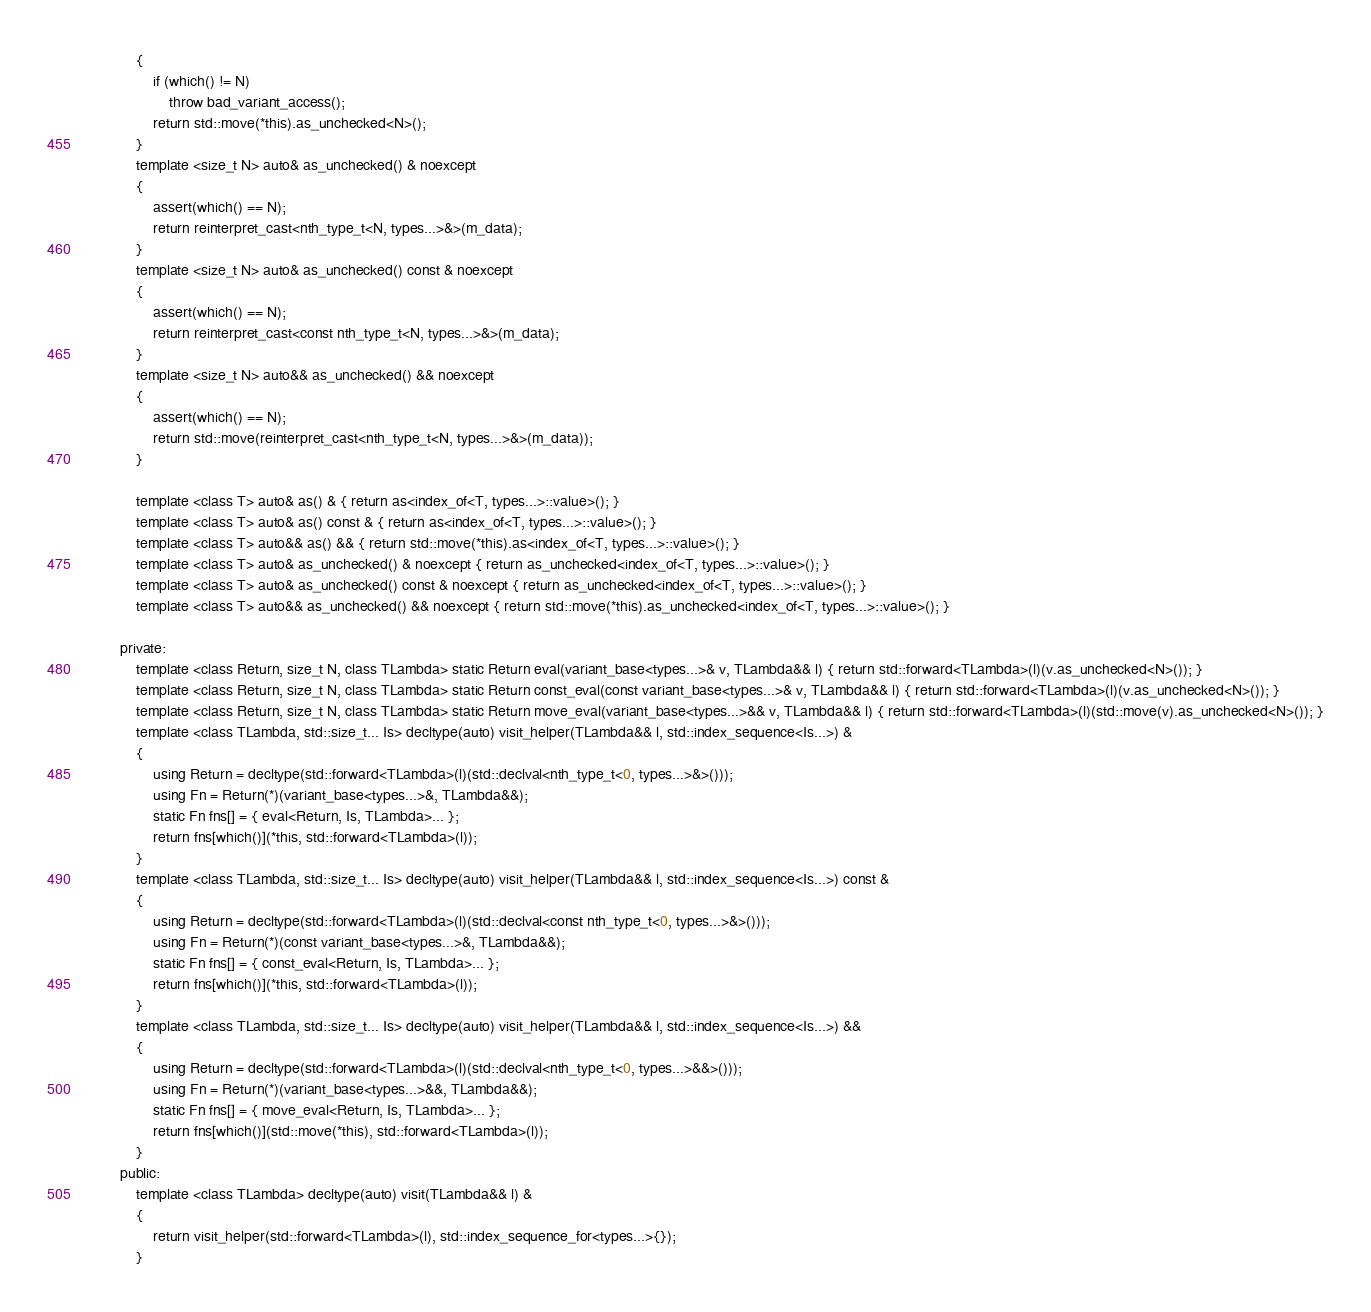Convert code to text. <code><loc_0><loc_0><loc_500><loc_500><_C_>			{
				if (which() != N)
					throw bad_variant_access();
				return std::move(*this).as_unchecked<N>();
			}
			template <size_t N> auto& as_unchecked() & noexcept
			{
				assert(which() == N);
				return reinterpret_cast<nth_type_t<N, types...>&>(m_data);
			}
			template <size_t N> auto& as_unchecked() const & noexcept
			{
				assert(which() == N);
				return reinterpret_cast<const nth_type_t<N, types...>&>(m_data);
			}
			template <size_t N> auto&& as_unchecked() && noexcept
			{
				assert(which() == N);
				return std::move(reinterpret_cast<nth_type_t<N, types...>&>(m_data));
			}

			template <class T> auto& as() & { return as<index_of<T, types...>::value>(); }
			template <class T> auto& as() const & { return as<index_of<T, types...>::value>(); }
			template <class T> auto&& as() && { return std::move(*this).as<index_of<T, types...>::value>(); }
			template <class T> auto& as_unchecked() & noexcept { return as_unchecked<index_of<T, types...>::value>(); }
			template <class T> auto& as_unchecked() const & noexcept { return as_unchecked<index_of<T, types...>::value>(); }
			template <class T> auto&& as_unchecked() && noexcept { return std::move(*this).as_unchecked<index_of<T, types...>::value>(); }

		private:
			template <class Return, size_t N, class TLambda> static Return eval(variant_base<types...>& v, TLambda&& l) { return std::forward<TLambda>(l)(v.as_unchecked<N>()); }
			template <class Return, size_t N, class TLambda> static Return const_eval(const variant_base<types...>& v, TLambda&& l) { return std::forward<TLambda>(l)(v.as_unchecked<N>()); }
			template <class Return, size_t N, class TLambda> static Return move_eval(variant_base<types...>&& v, TLambda&& l) { return std::forward<TLambda>(l)(std::move(v).as_unchecked<N>()); }
			template <class TLambda, std::size_t... Is> decltype(auto) visit_helper(TLambda&& l, std::index_sequence<Is...>) &
			{
				using Return = decltype(std::forward<TLambda>(l)(std::declval<nth_type_t<0, types...>&>()));
				using Fn = Return(*)(variant_base<types...>&, TLambda&&);
				static Fn fns[] = { eval<Return, Is, TLambda>... };
				return fns[which()](*this, std::forward<TLambda>(l));
			}
			template <class TLambda, std::size_t... Is> decltype(auto) visit_helper(TLambda&& l, std::index_sequence<Is...>) const &
			{
				using Return = decltype(std::forward<TLambda>(l)(std::declval<const nth_type_t<0, types...>&>()));
				using Fn = Return(*)(const variant_base<types...>&, TLambda&&);
				static Fn fns[] = { const_eval<Return, Is, TLambda>... };
				return fns[which()](*this, std::forward<TLambda>(l));
			}
			template <class TLambda, std::size_t... Is> decltype(auto) visit_helper(TLambda&& l, std::index_sequence<Is...>) &&
			{
				using Return = decltype(std::forward<TLambda>(l)(std::declval<nth_type_t<0, types...>&&>()));
				using Fn = Return(*)(variant_base<types...>&&, TLambda&&);
				static Fn fns[] = { move_eval<Return, Is, TLambda>... };
				return fns[which()](std::move(*this), std::forward<TLambda>(l));
			}
		public:
			template <class TLambda> decltype(auto) visit(TLambda&& l) &
			{
				return visit_helper(std::forward<TLambda>(l), std::index_sequence_for<types...>{});
			}</code> 